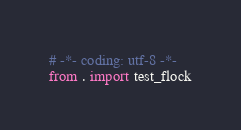Convert code to text. <code><loc_0><loc_0><loc_500><loc_500><_Python_># -*- coding: utf-8 -*-
from . import test_flock
</code> 